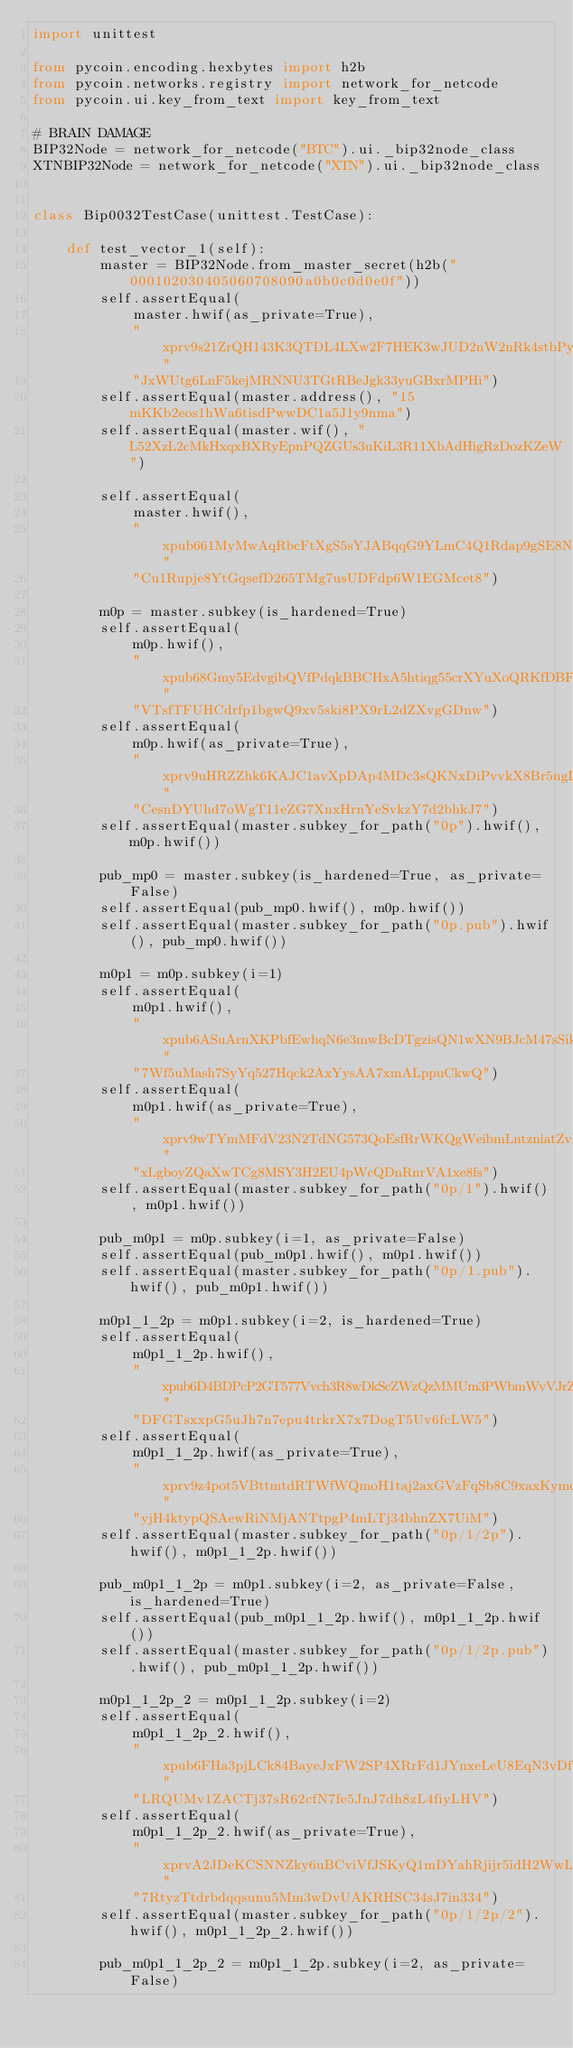Convert code to text. <code><loc_0><loc_0><loc_500><loc_500><_Python_>import unittest

from pycoin.encoding.hexbytes import h2b
from pycoin.networks.registry import network_for_netcode
from pycoin.ui.key_from_text import key_from_text

# BRAIN DAMAGE
BIP32Node = network_for_netcode("BTC").ui._bip32node_class
XTNBIP32Node = network_for_netcode("XTN").ui._bip32node_class


class Bip0032TestCase(unittest.TestCase):

    def test_vector_1(self):
        master = BIP32Node.from_master_secret(h2b("000102030405060708090a0b0c0d0e0f"))
        self.assertEqual(
            master.hwif(as_private=True),
            "xprv9s21ZrQH143K3QTDL4LXw2F7HEK3wJUD2nW2nRk4stbPy6cq3jPPqjiChkVvvNKmPG"
            "JxWUtg6LnF5kejMRNNU3TGtRBeJgk33yuGBxrMPHi")
        self.assertEqual(master.address(), "15mKKb2eos1hWa6tisdPwwDC1a5J1y9nma")
        self.assertEqual(master.wif(), "L52XzL2cMkHxqxBXRyEpnPQZGUs3uKiL3R11XbAdHigRzDozKZeW")

        self.assertEqual(
            master.hwif(),
            "xpub661MyMwAqRbcFtXgS5sYJABqqG9YLmC4Q1Rdap9gSE8NqtwybGhePY2gZ29ESFjqJo"
            "Cu1Rupje8YtGqsefD265TMg7usUDFdp6W1EGMcet8")

        m0p = master.subkey(is_hardened=True)
        self.assertEqual(
            m0p.hwif(),
            "xpub68Gmy5EdvgibQVfPdqkBBCHxA5htiqg55crXYuXoQRKfDBFA1WEjWgP6LHhwBZeNK1"
            "VTsfTFUHCdrfp1bgwQ9xv5ski8PX9rL2dZXvgGDnw")
        self.assertEqual(
            m0p.hwif(as_private=True),
            "xprv9uHRZZhk6KAJC1avXpDAp4MDc3sQKNxDiPvvkX8Br5ngLNv1TxvUxt4cV1rGL5hj6K"
            "CesnDYUhd7oWgT11eZG7XnxHrnYeSvkzY7d2bhkJ7")
        self.assertEqual(master.subkey_for_path("0p").hwif(), m0p.hwif())

        pub_mp0 = master.subkey(is_hardened=True, as_private=False)
        self.assertEqual(pub_mp0.hwif(), m0p.hwif())
        self.assertEqual(master.subkey_for_path("0p.pub").hwif(), pub_mp0.hwif())

        m0p1 = m0p.subkey(i=1)
        self.assertEqual(
            m0p1.hwif(),
            "xpub6ASuArnXKPbfEwhqN6e3mwBcDTgzisQN1wXN9BJcM47sSikHjJf3UFHKkNAWbWMiGj"
            "7Wf5uMash7SyYq527Hqck2AxYysAA7xmALppuCkwQ")
        self.assertEqual(
            m0p1.hwif(as_private=True),
            "xprv9wTYmMFdV23N2TdNG573QoEsfRrWKQgWeibmLntzniatZvR9BmLnvSxqu53Kw1UmYP"
            "xLgboyZQaXwTCg8MSY3H2EU4pWcQDnRnrVA1xe8fs")
        self.assertEqual(master.subkey_for_path("0p/1").hwif(), m0p1.hwif())

        pub_m0p1 = m0p.subkey(i=1, as_private=False)
        self.assertEqual(pub_m0p1.hwif(), m0p1.hwif())
        self.assertEqual(master.subkey_for_path("0p/1.pub").hwif(), pub_m0p1.hwif())

        m0p1_1_2p = m0p1.subkey(i=2, is_hardened=True)
        self.assertEqual(
            m0p1_1_2p.hwif(),
            "xpub6D4BDPcP2GT577Vvch3R8wDkScZWzQzMMUm3PWbmWvVJrZwQY4VUNgqFJPMM3No2dF"
            "DFGTsxxpG5uJh7n7epu4trkrX7x7DogT5Uv6fcLW5")
        self.assertEqual(
            m0p1_1_2p.hwif(as_private=True),
            "xprv9z4pot5VBttmtdRTWfWQmoH1taj2axGVzFqSb8C9xaxKymcFzXBDptWmT7FwuEzG3r"
            "yjH4ktypQSAewRiNMjANTtpgP4mLTj34bhnZX7UiM")
        self.assertEqual(master.subkey_for_path("0p/1/2p").hwif(), m0p1_1_2p.hwif())

        pub_m0p1_1_2p = m0p1.subkey(i=2, as_private=False, is_hardened=True)
        self.assertEqual(pub_m0p1_1_2p.hwif(), m0p1_1_2p.hwif())
        self.assertEqual(master.subkey_for_path("0p/1/2p.pub").hwif(), pub_m0p1_1_2p.hwif())

        m0p1_1_2p_2 = m0p1_1_2p.subkey(i=2)
        self.assertEqual(
            m0p1_1_2p_2.hwif(),
            "xpub6FHa3pjLCk84BayeJxFW2SP4XRrFd1JYnxeLeU8EqN3vDfZmbqBqaGJAyiLjTAwm6Z"
            "LRQUMv1ZACTj37sR62cfN7fe5JnJ7dh8zL4fiyLHV")
        self.assertEqual(
            m0p1_1_2p_2.hwif(as_private=True),
            "xprvA2JDeKCSNNZky6uBCviVfJSKyQ1mDYahRjijr5idH2WwLsEd4Hsb2Tyh8RfQMuPh7f"
            "7RtyzTtdrbdqqsunu5Mm3wDvUAKRHSC34sJ7in334")
        self.assertEqual(master.subkey_for_path("0p/1/2p/2").hwif(), m0p1_1_2p_2.hwif())

        pub_m0p1_1_2p_2 = m0p1_1_2p.subkey(i=2, as_private=False)</code> 